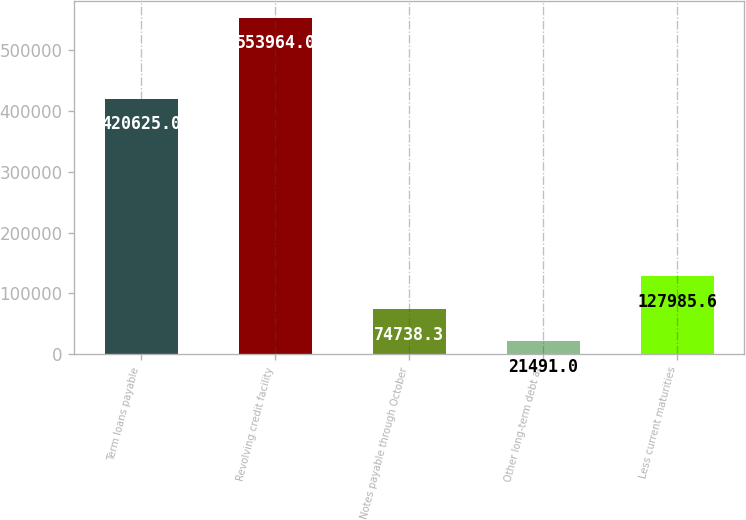<chart> <loc_0><loc_0><loc_500><loc_500><bar_chart><fcel>Term loans payable<fcel>Revolving credit facility<fcel>Notes payable through October<fcel>Other long-term debt at<fcel>Less current maturities<nl><fcel>420625<fcel>553964<fcel>74738.3<fcel>21491<fcel>127986<nl></chart> 